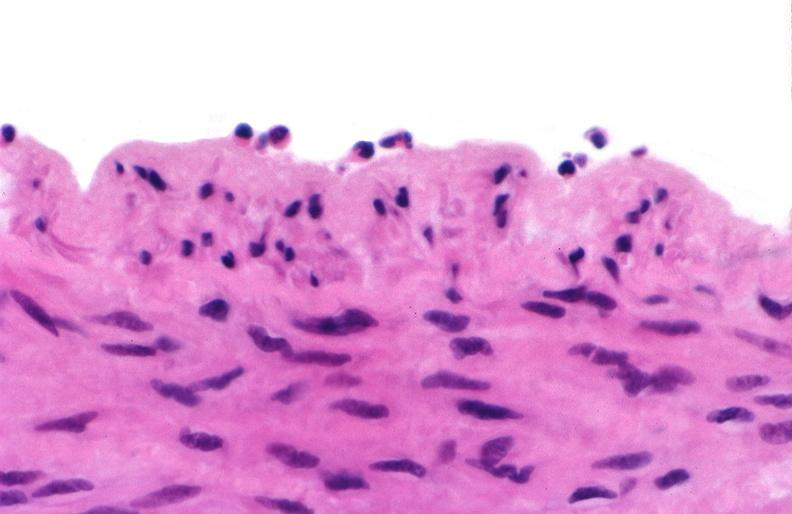what is present?
Answer the question using a single word or phrase. Vasculature 